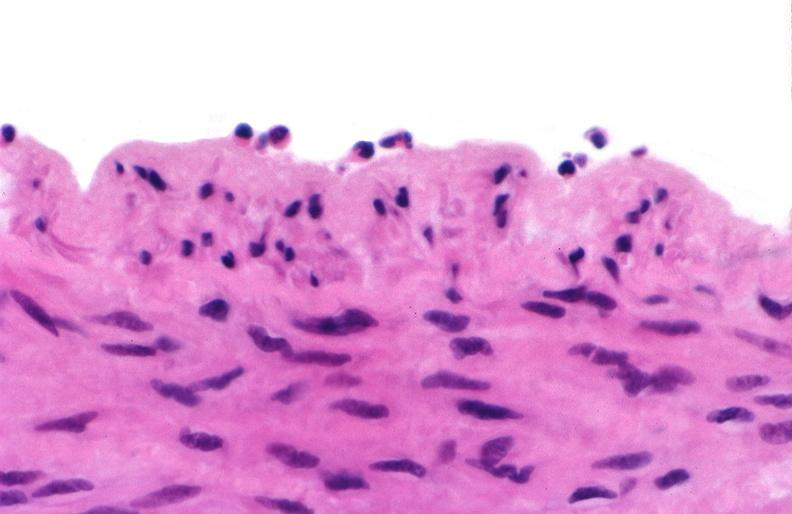what is present?
Answer the question using a single word or phrase. Vasculature 